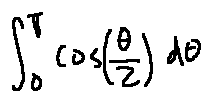Convert formula to latex. <formula><loc_0><loc_0><loc_500><loc_500>\int \lim i t s _ { 0 } ^ { \pi } \cos ( \frac { \theta } { 2 } ) d \theta</formula> 